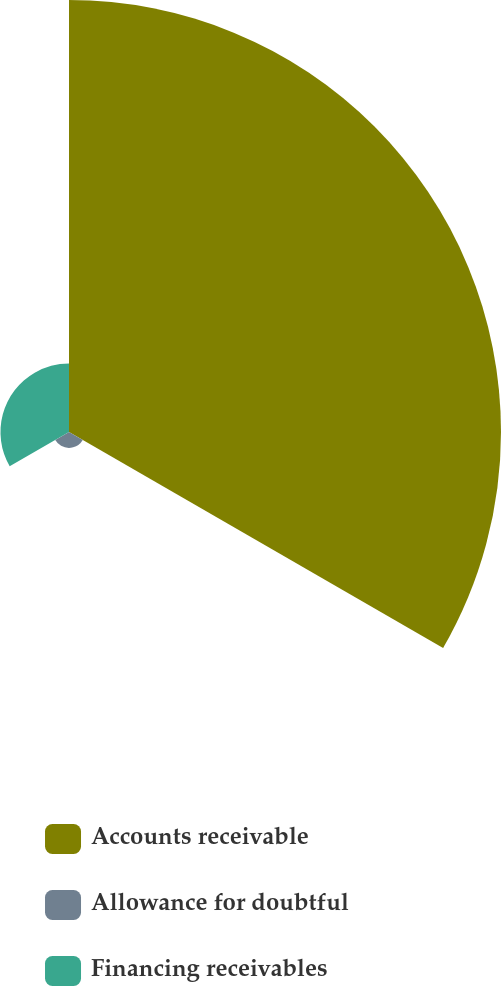Convert chart to OTSL. <chart><loc_0><loc_0><loc_500><loc_500><pie_chart><fcel>Accounts receivable<fcel>Allowance for doubtful<fcel>Financing receivables<nl><fcel>83.66%<fcel>3.07%<fcel>13.27%<nl></chart> 